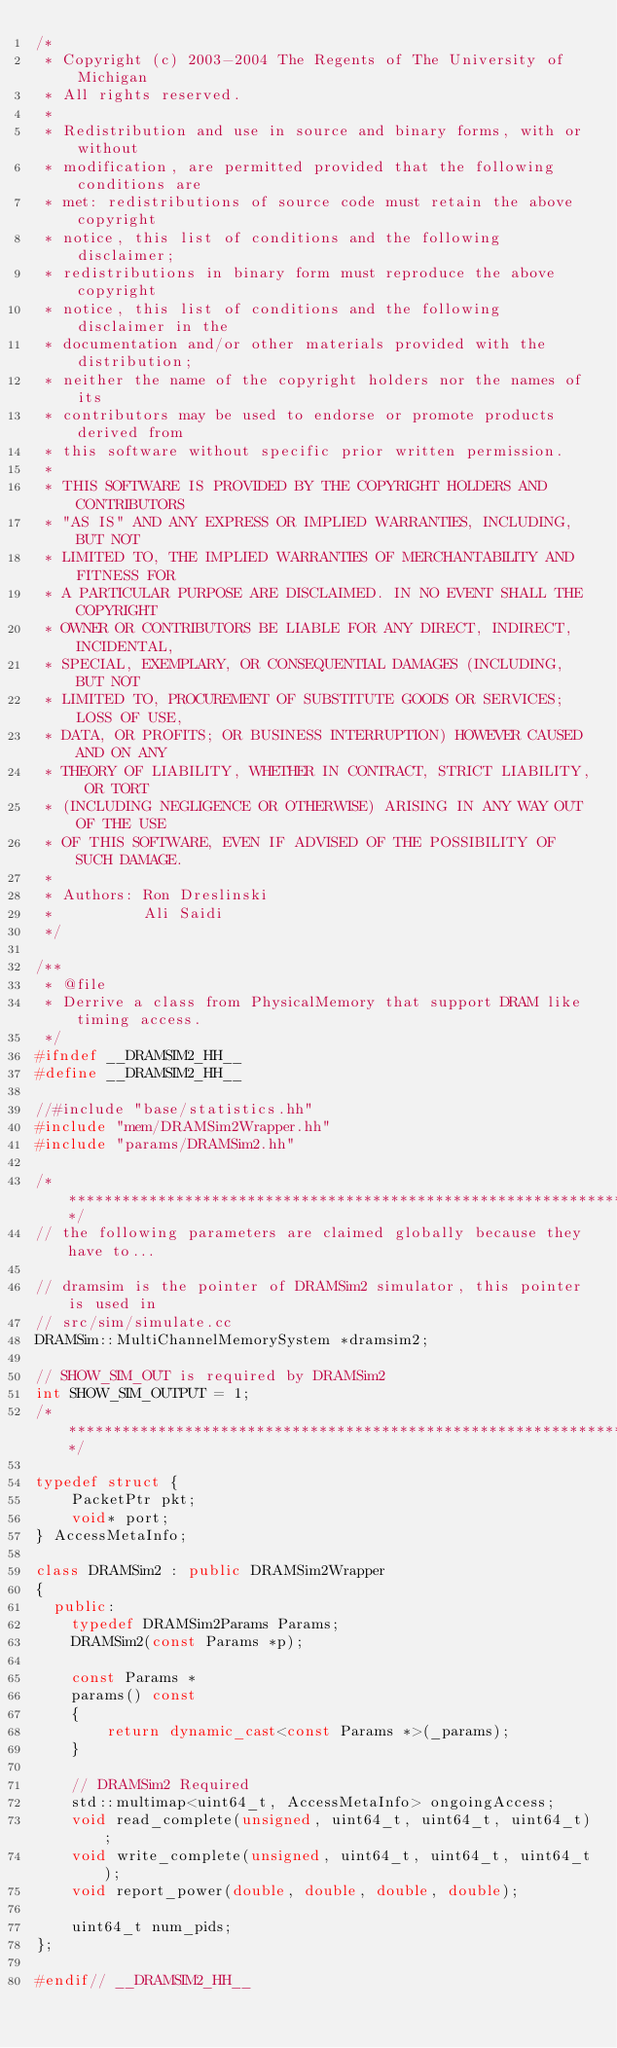Convert code to text. <code><loc_0><loc_0><loc_500><loc_500><_C++_>/*
 * Copyright (c) 2003-2004 The Regents of The University of Michigan
 * All rights reserved.
 *
 * Redistribution and use in source and binary forms, with or without
 * modification, are permitted provided that the following conditions are
 * met: redistributions of source code must retain the above copyright
 * notice, this list of conditions and the following disclaimer;
 * redistributions in binary form must reproduce the above copyright
 * notice, this list of conditions and the following disclaimer in the
 * documentation and/or other materials provided with the distribution;
 * neither the name of the copyright holders nor the names of its
 * contributors may be used to endorse or promote products derived from
 * this software without specific prior written permission.
 *
 * THIS SOFTWARE IS PROVIDED BY THE COPYRIGHT HOLDERS AND CONTRIBUTORS
 * "AS IS" AND ANY EXPRESS OR IMPLIED WARRANTIES, INCLUDING, BUT NOT
 * LIMITED TO, THE IMPLIED WARRANTIES OF MERCHANTABILITY AND FITNESS FOR
 * A PARTICULAR PURPOSE ARE DISCLAIMED. IN NO EVENT SHALL THE COPYRIGHT
 * OWNER OR CONTRIBUTORS BE LIABLE FOR ANY DIRECT, INDIRECT, INCIDENTAL,
 * SPECIAL, EXEMPLARY, OR CONSEQUENTIAL DAMAGES (INCLUDING, BUT NOT
 * LIMITED TO, PROCUREMENT OF SUBSTITUTE GOODS OR SERVICES; LOSS OF USE,
 * DATA, OR PROFITS; OR BUSINESS INTERRUPTION) HOWEVER CAUSED AND ON ANY
 * THEORY OF LIABILITY, WHETHER IN CONTRACT, STRICT LIABILITY, OR TORT
 * (INCLUDING NEGLIGENCE OR OTHERWISE) ARISING IN ANY WAY OUT OF THE USE
 * OF THIS SOFTWARE, EVEN IF ADVISED OF THE POSSIBILITY OF SUCH DAMAGE.
 *
 * Authors: Ron Dreslinski
 *          Ali Saidi
 */

/**
 * @file
 * Derrive a class from PhysicalMemory that support DRAM like timing access.
 */
#ifndef __DRAMSIM2_HH__
#define __DRAMSIM2_HH__

//#include "base/statistics.hh"
#include "mem/DRAMSim2Wrapper.hh"
#include "params/DRAMSim2.hh"

/**********************************************************************/
// the following parameters are claimed globally because they have to...

// dramsim is the pointer of DRAMSim2 simulator, this pointer is used in 
// src/sim/simulate.cc
DRAMSim::MultiChannelMemorySystem *dramsim2;

// SHOW_SIM_OUT is required by DRAMSim2
int SHOW_SIM_OUTPUT = 1;
/**********************************************************************/

typedef struct {
    PacketPtr pkt;
    void* port;
} AccessMetaInfo;

class DRAMSim2 : public DRAMSim2Wrapper
{
  public:
    typedef DRAMSim2Params Params;
    DRAMSim2(const Params *p);

    const Params *
    params() const
    {
        return dynamic_cast<const Params *>(_params);
    }
  
    // DRAMSim2 Required
    std::multimap<uint64_t, AccessMetaInfo> ongoingAccess;
    void read_complete(unsigned, uint64_t, uint64_t, uint64_t);
    void write_complete(unsigned, uint64_t, uint64_t, uint64_t);
    void report_power(double, double, double, double);
    
    uint64_t num_pids;
};

#endif// __DRAMSIM2_HH__
</code> 